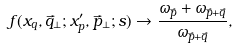<formula> <loc_0><loc_0><loc_500><loc_500>f ( x _ { q } , \vec { q } _ { \perp } ; x ^ { \prime } _ { p } , \vec { p } _ { \perp } ; s ) \to \frac { \omega _ { \vec { p } } + \omega _ { \vec { p } + \vec { q } } } { \omega _ { \vec { p } + \vec { q } } } ,</formula> 